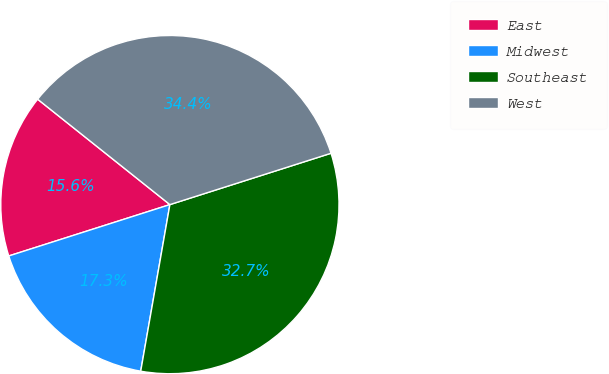Convert chart. <chart><loc_0><loc_0><loc_500><loc_500><pie_chart><fcel>East<fcel>Midwest<fcel>Southeast<fcel>West<nl><fcel>15.62%<fcel>17.33%<fcel>32.67%<fcel>34.38%<nl></chart> 